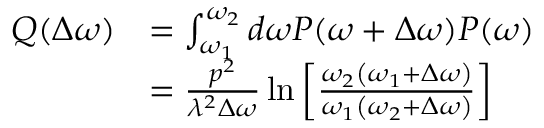<formula> <loc_0><loc_0><loc_500><loc_500>\begin{array} { r l } { Q ( \Delta \omega ) } & { = \int _ { \omega _ { 1 } } ^ { \omega _ { 2 } } d \omega P ( \omega + \Delta \omega ) P ( \omega ) } \\ & { = \frac { p ^ { 2 } } { \lambda ^ { 2 } \Delta \omega } \ln \left [ \frac { \omega _ { 2 } \left ( \omega _ { 1 } + \Delta \omega \right ) } { \omega _ { 1 } \left ( \omega _ { 2 } + \Delta \omega \right ) } \right ] } \end{array}</formula> 